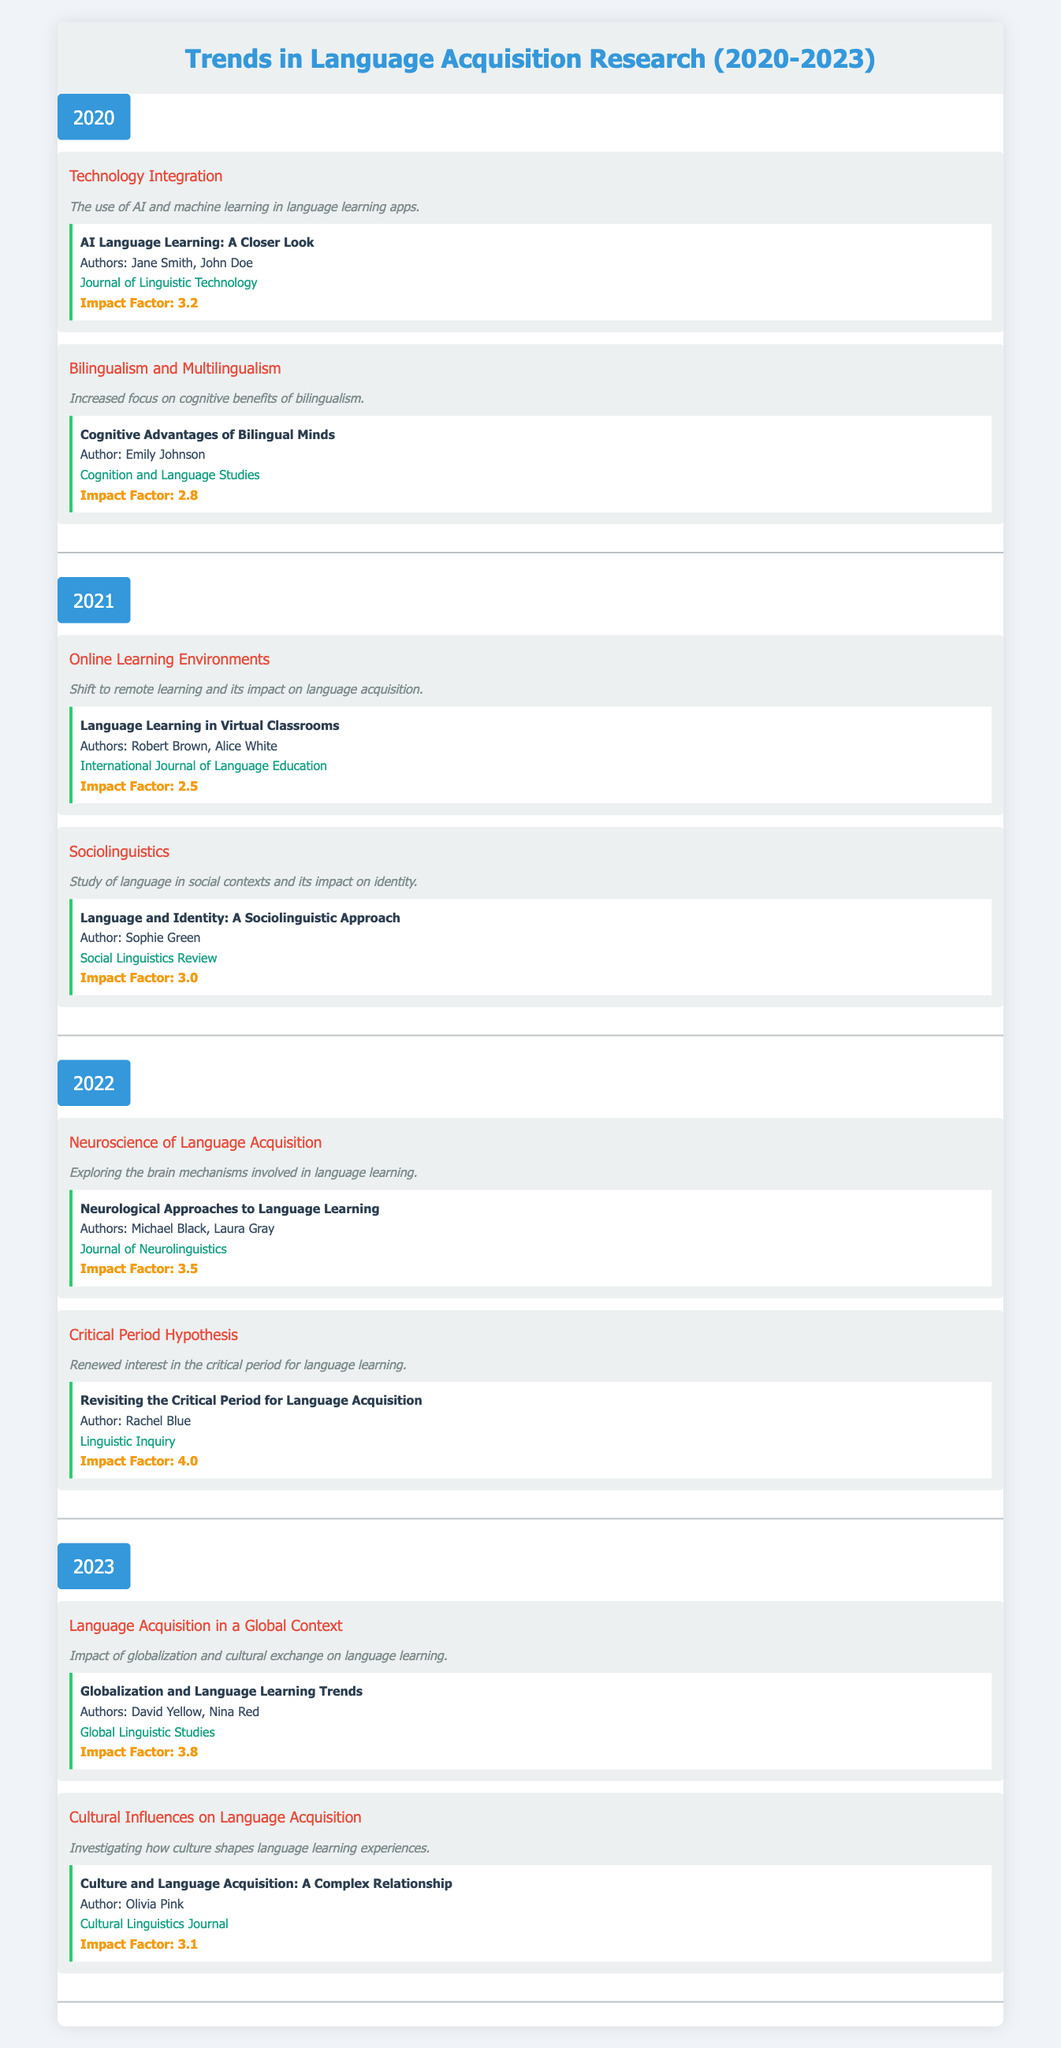What notable study was published in 2020 about technology integration in language acquisition? In 2020, the notable study related to technology integration is titled "AI Language Learning: A Closer Look," authored by Jane Smith and John Doe, published in the Journal of Linguistic Technology.
Answer: AI Language Learning: A Closer Look What is the impact factor of the study "Neurological Approaches to Language Learning"? The study "Neurological Approaches to Language Learning," published in 2022, has an impact factor of 3.5 as indicated in the table.
Answer: 3.5 Is there a study focusing on online learning that has an impact factor greater than 2.5? The study "Language Learning in Virtual Classrooms" has an impact factor of 2.5, which is not greater than 2.5. Therefore, the answer is no.
Answer: No Which year saw the publication of the study "Cognitive Advantages of Bilingual Minds"? This study was published in 2020, focusing on bilingualism and its cognitive benefits as noted in the table.
Answer: 2020 How many notable studies were published in 2021? In 2021, there were two notable studies listed: one on online learning environments and another on sociolinguistics. Thus, the total number is 2.
Answer: 2 What is the title of the 2022 study that discusses the critical period hypothesis? The title of the study from 2022 discussing the critical period hypothesis is "Revisiting the Critical Period for Language Acquisition."
Answer: Revisiting the Critical Period for Language Acquisition Did the study "Culture and Language Acquisition: A Complex Relationship" have a higher impact factor than the study from 2020 on bilingualism? The study "Culture and Language Acquisition: A Complex Relationship" has an impact factor of 3.1, while the 2020 bilingualism study has an impact factor of 2.8. Since 3.1 is greater than 2.8, the answer is yes.
Answer: Yes What trend related to language acquisition was highlighted in 2023? In 2023, one highlighted trend in language acquisition research was "Language Acquisition in a Global Context," focusing on globalization's impact on language learning.
Answer: Language Acquisition in a Global Context Which notable study had the highest impact factor in the table? The study with the highest impact factor is "Revisiting the Critical Period for Language Acquisition," published in 2022, with an impact factor of 4.0.
Answer: Revisiting the Critical Period for Language Acquisition 